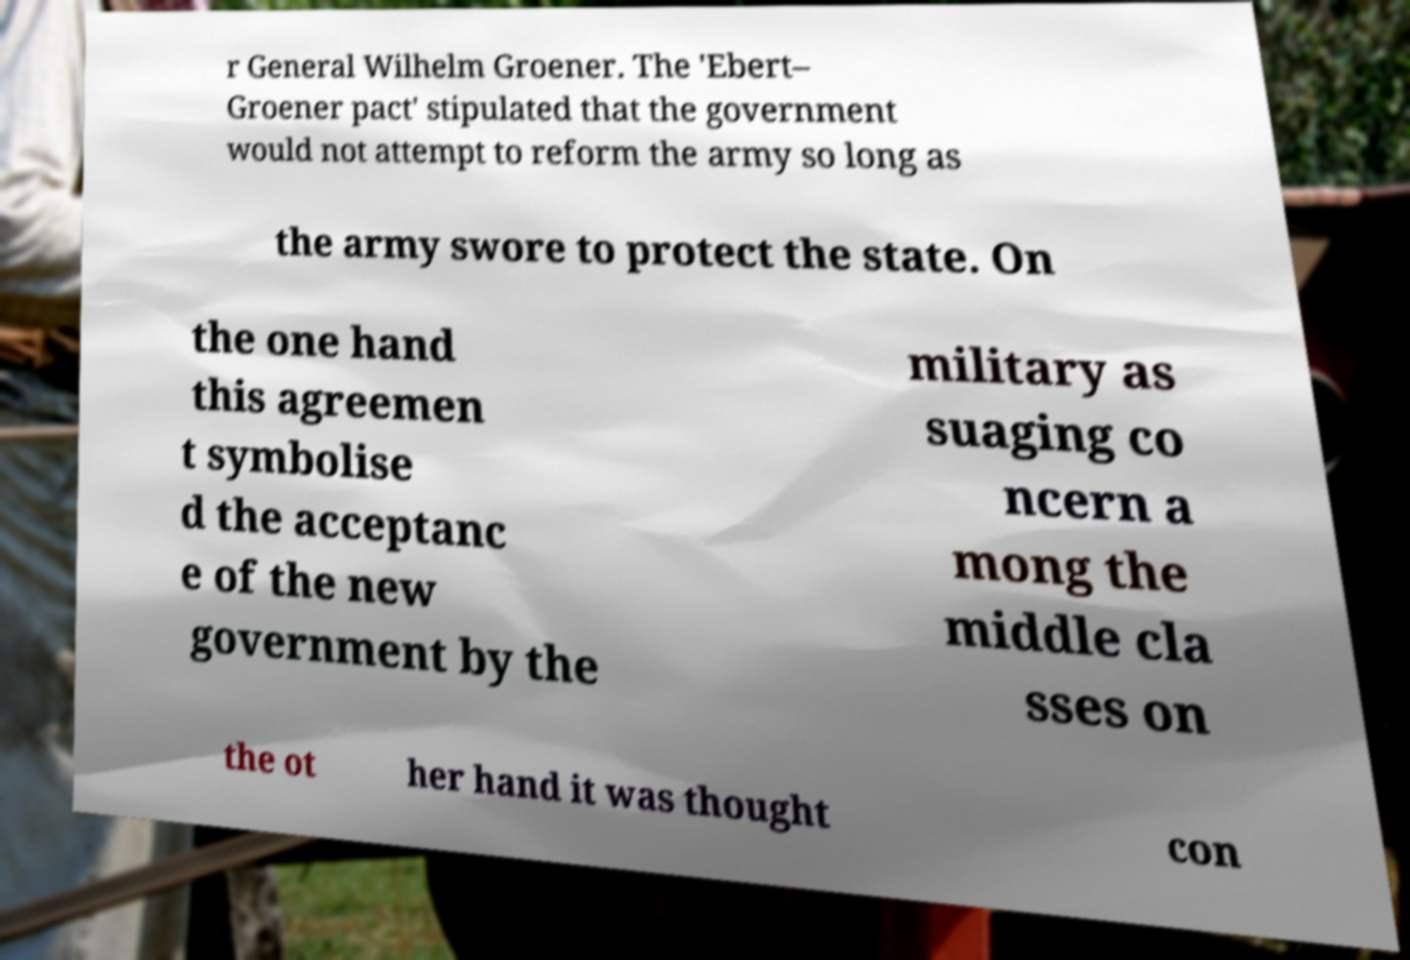Could you extract and type out the text from this image? r General Wilhelm Groener. The 'Ebert– Groener pact' stipulated that the government would not attempt to reform the army so long as the army swore to protect the state. On the one hand this agreemen t symbolise d the acceptanc e of the new government by the military as suaging co ncern a mong the middle cla sses on the ot her hand it was thought con 